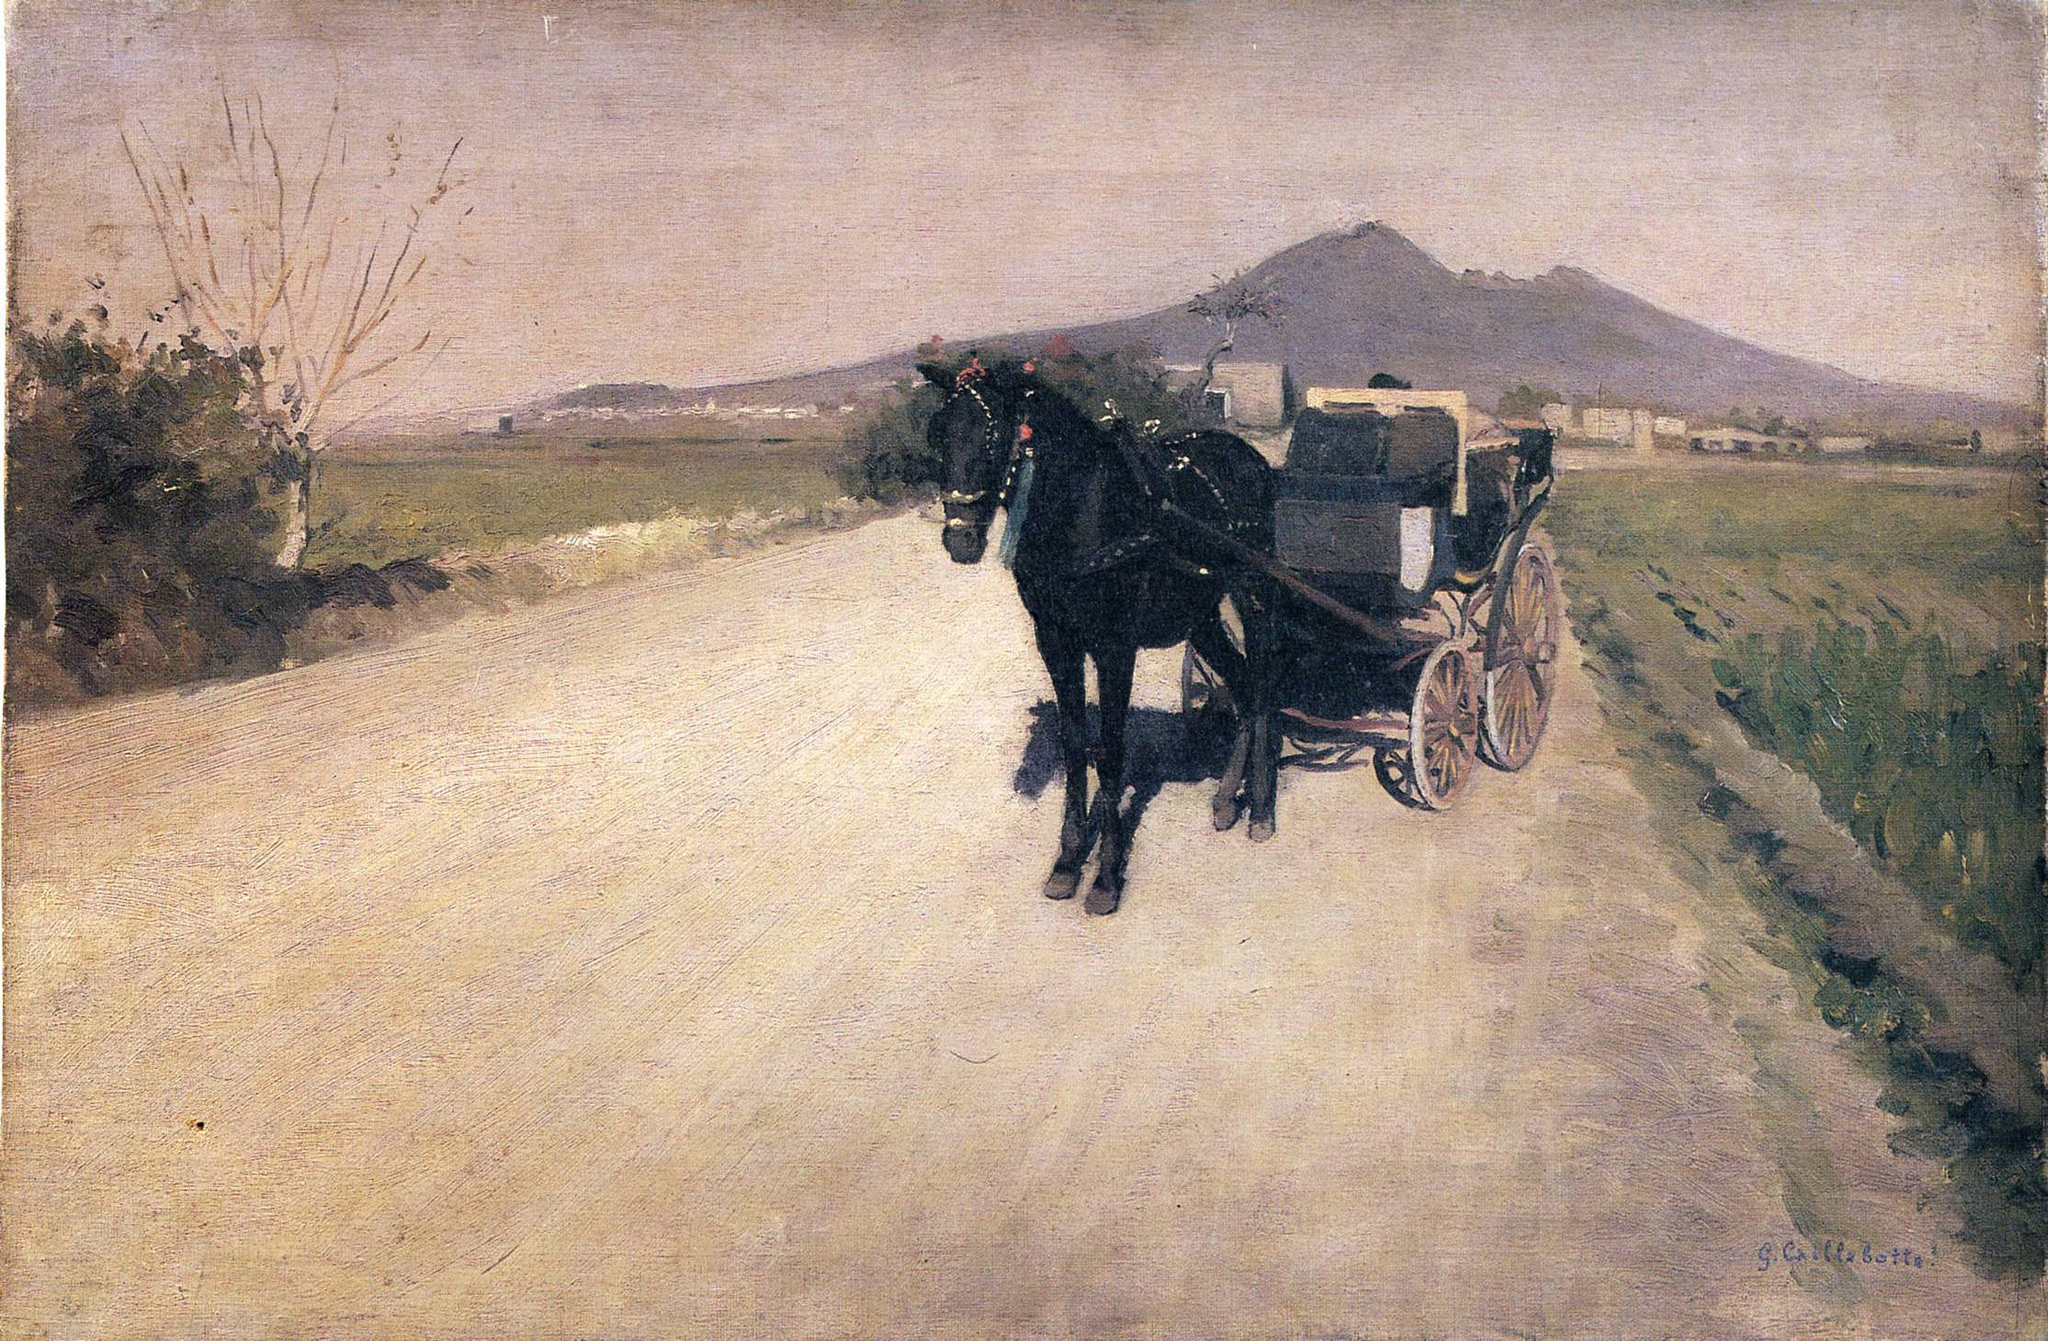What does the carriage in the artwork symbolize? In this painting, the carriage could symbolize progress and movement, set against the backdrop of a changing rural landscape that perhaps hints at the broader transformations occurring in 19th-century society. It might reflect the juxtaposition of progress powered by industrial advancements with the untouched, serene nature of rural life, offering a reflection on the temporal changes and the enduring values of the countryside. 